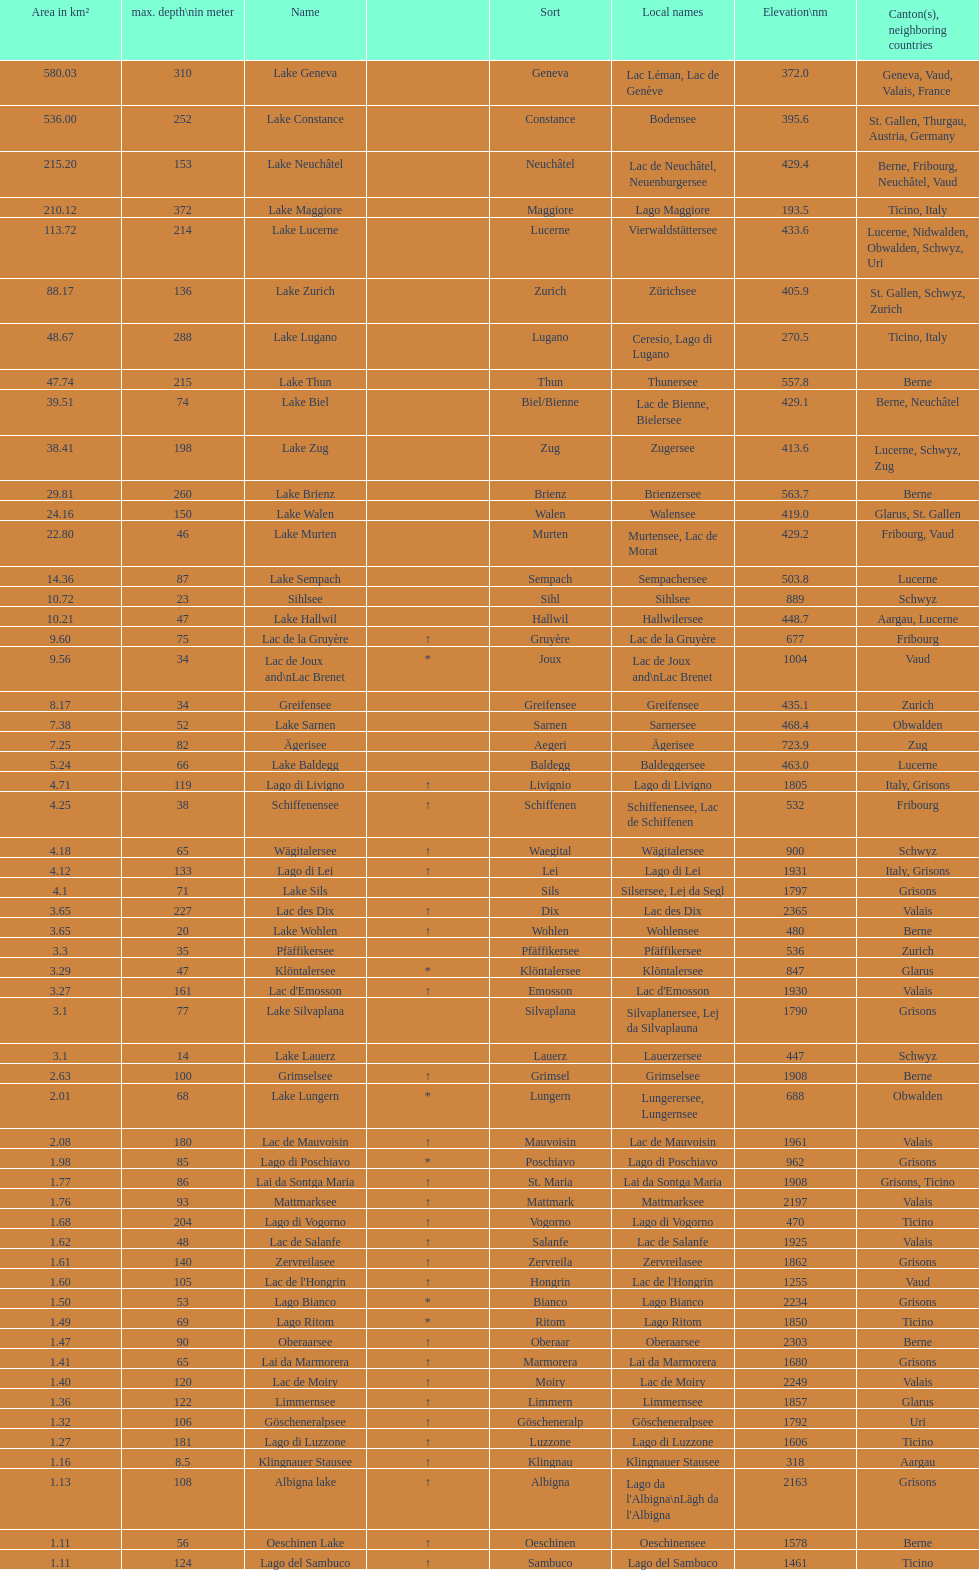What is the total area in km² of lake sils? 4.1. 